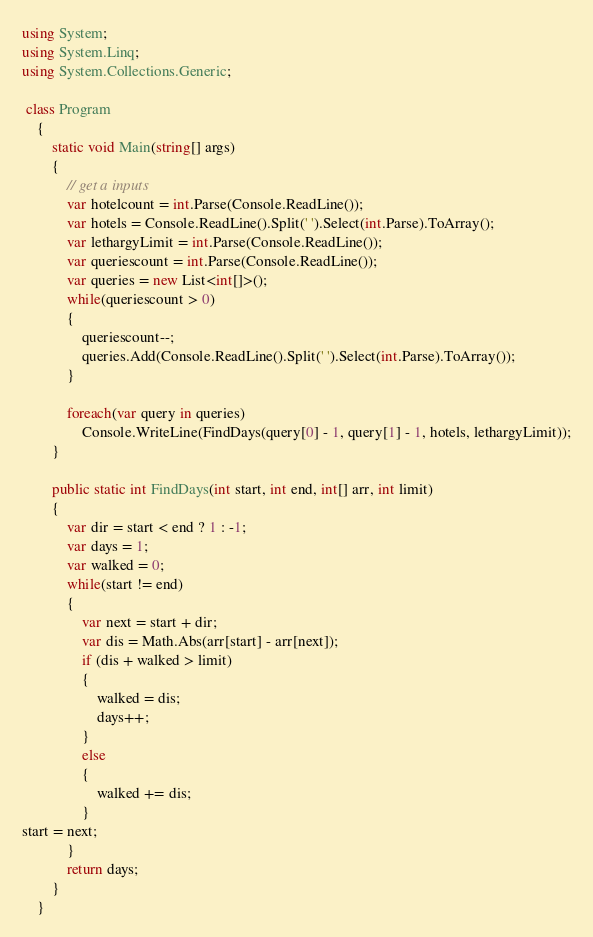<code> <loc_0><loc_0><loc_500><loc_500><_C#_>using System;
using System.Linq;
using System.Collections.Generic;

 class Program
    {
        static void Main(string[] args)
        {
            // get a inputs
            var hotelcount = int.Parse(Console.ReadLine());
            var hotels = Console.ReadLine().Split(' ').Select(int.Parse).ToArray();
            var lethargyLimit = int.Parse(Console.ReadLine());
            var queriescount = int.Parse(Console.ReadLine());
            var queries = new List<int[]>();
            while(queriescount > 0)
            {
                queriescount--;
                queries.Add(Console.ReadLine().Split(' ').Select(int.Parse).ToArray());
            }

            foreach(var query in queries)
                Console.WriteLine(FindDays(query[0] - 1, query[1] - 1, hotels, lethargyLimit));
        }

        public static int FindDays(int start, int end, int[] arr, int limit)
        {
            var dir = start < end ? 1 : -1;
            var days = 1;
            var walked = 0;
            while(start != end)
            {
                var next = start + dir;
                var dis = Math.Abs(arr[start] - arr[next]);
                if (dis + walked > limit)
                {
                    walked = dis;
                    days++;
                }
                else
                {
                    walked += dis;
                }
start = next;
            }
            return days;
        }
    }</code> 